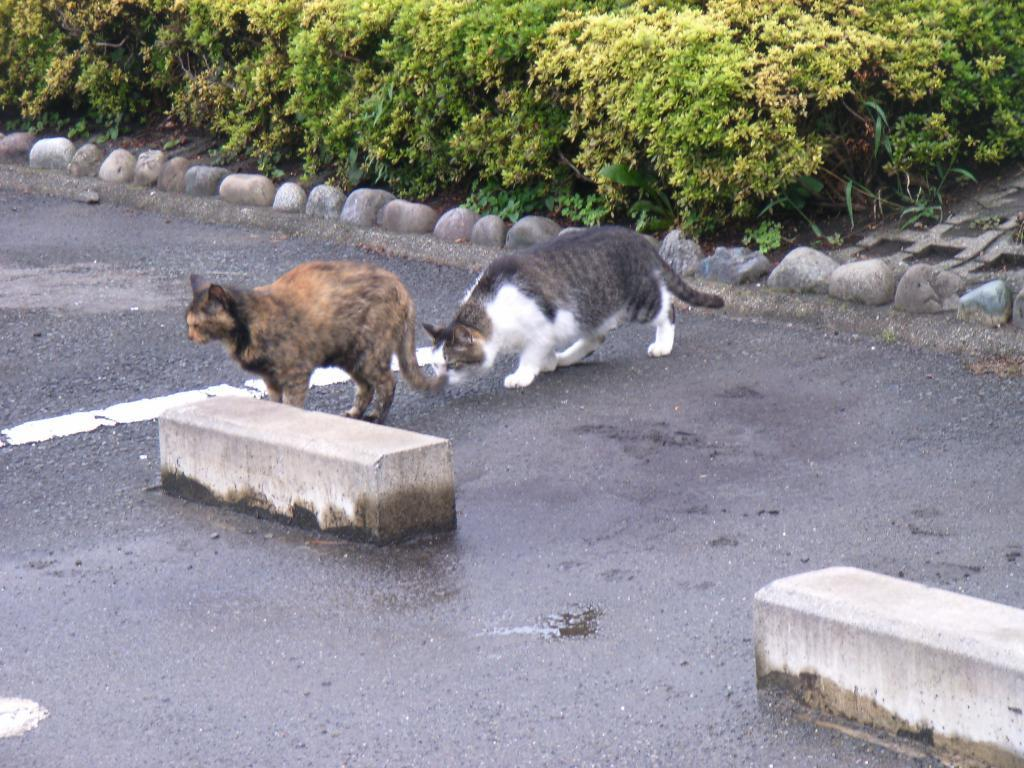What animals can be seen on the road in the image? There are two cats on the road in the image. What type of natural elements are visible in the image? There are stones and plants visible in the image. What direction is the star moving in the image? There is no star present in the image. What type of cable can be seen connecting the plants in the image? There is no cable visible in the image; it only features two cats, stones, and plants. 